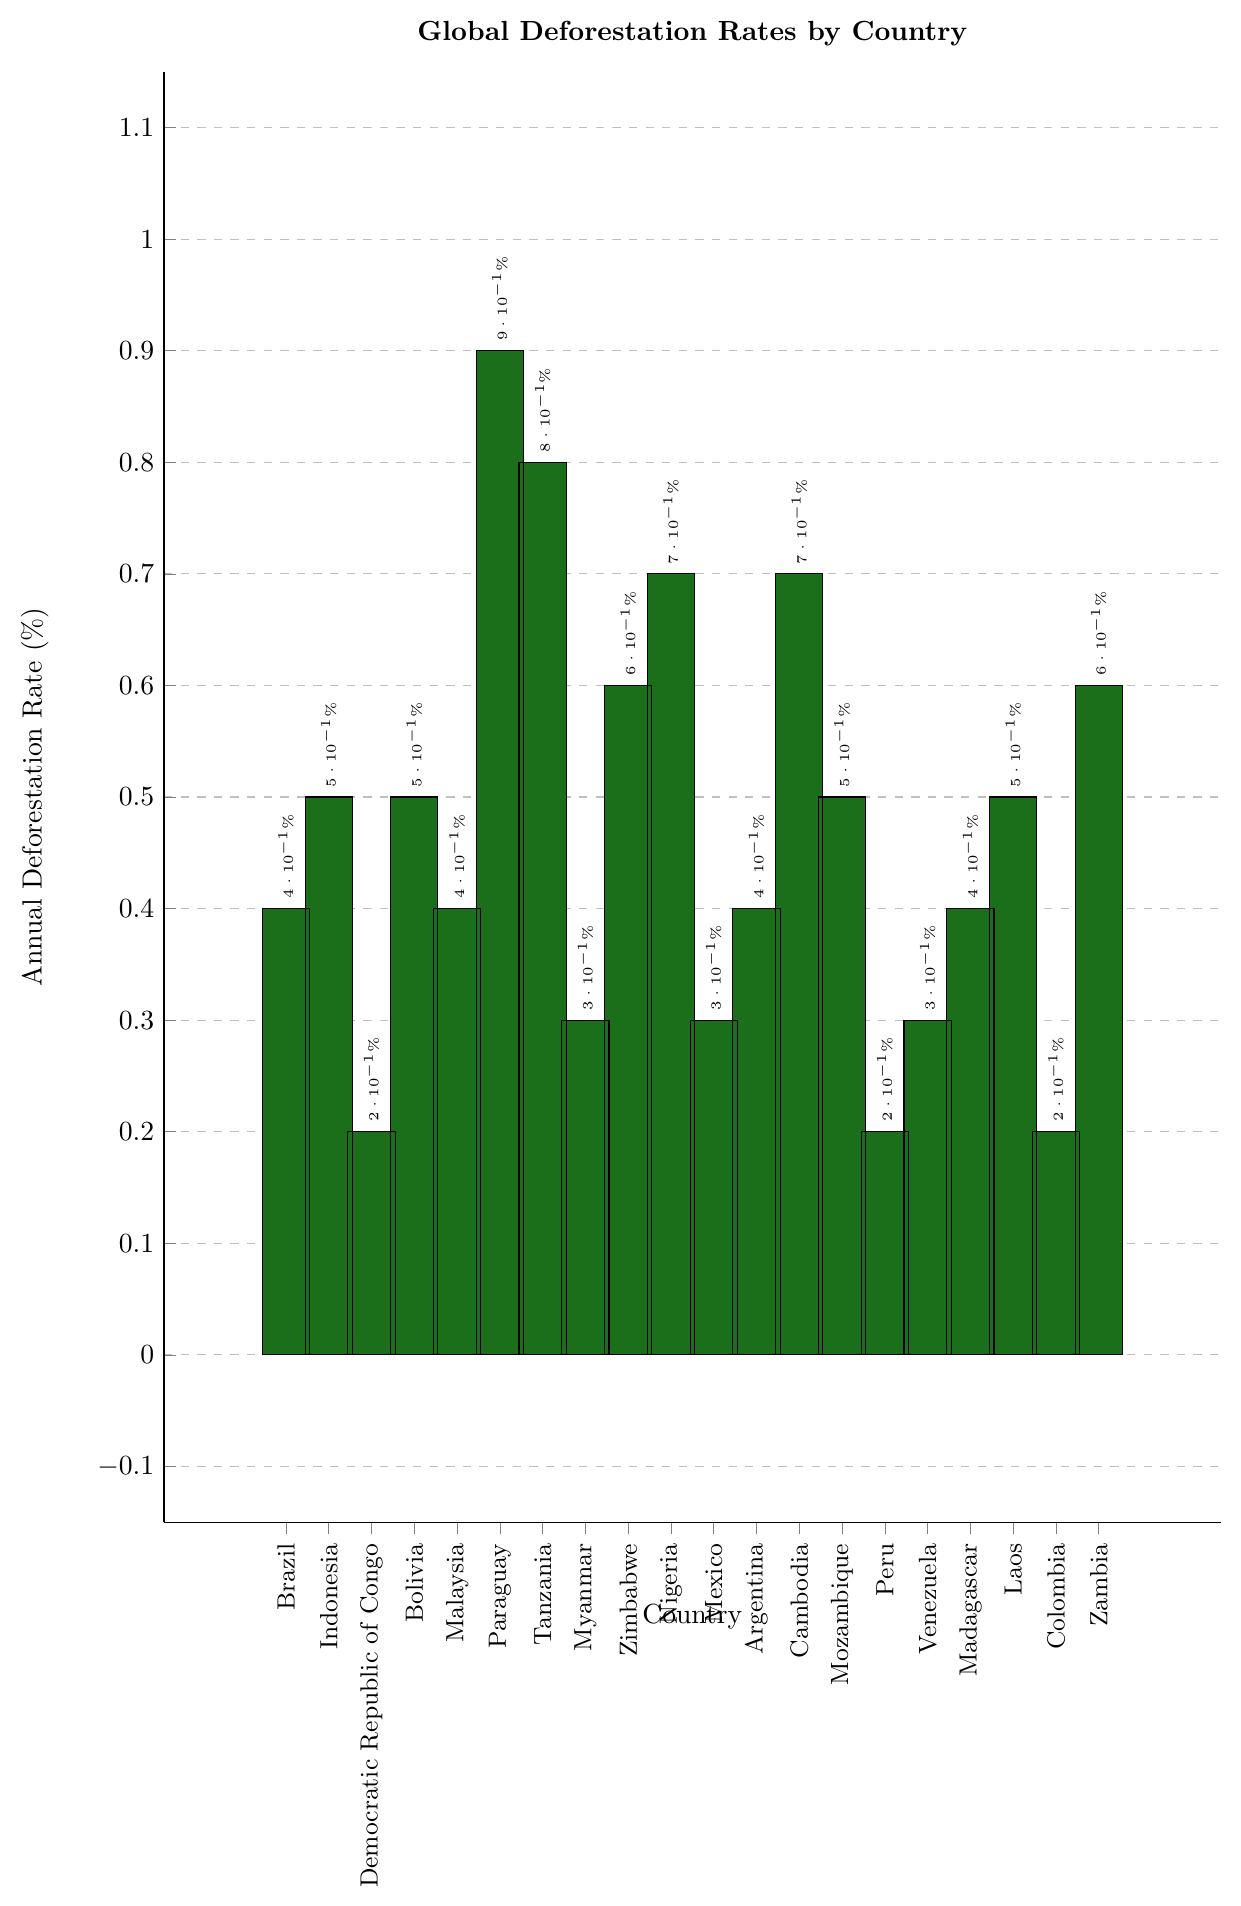What is the country with the highest deforestation rate? According to the chart, we observe the bars and compare their heights. Paraguay has the highest bar, indicating its annual deforestation rate.
Answer: Paraguay Which two countries have the same deforestation rate of 0.40%? To answer this, we examine the figure and find bars of the same height at 0.40%. Brazil, Malaysia, Argentina, and Madagascar all have the same height, so any combination of two from these countries is correct.
Answer: Brazil and Malaysia How much higher is Tanzania's deforestation rate compared to Zimbabwe's? Tanzania's deforestation rate is 0.80%, and Zimbabwe's is 0.60%. Subtract Zimbabwe's rate from Tanzania's rate (0.80% - 0.60%).
Answer: 0.20% Identify the country with an annual deforestation rate of 0.50% and caused by palm oil plantations. We need to find the country with a bar at 0.50% height and match with the provided data on causes. Indonesia fits this description.
Answer: Indonesia What is the average deforestation rate of the countries in the chart? Sum the deforestation rates of all countries: (0.40 + 0.50 + 0.20 + 0.50 + 0.40 + 0.90 + 0.80 + 0.30 + 0.60 + 0.70 + 0.30 + 0.40 + 0.70 + 0.50 + 0.20 + 0.30 + 0.40 + 0.50 + 0.20 + 0.60) = 10.60. Divide by the number of countries (20).
Answer: 0.53% Which country has a higher deforestation rate, Mozambique or Myanmar? Comparing the heights of the bars, Mozambique's bar at 0.50% is higher than Myanmar's at 0.30%.
Answer: Mozambique What is the sum of deforestation rates for countries involved in soybean cultivation? Identify the countries with "Soybean cultivation" as the cause (Bolivia, Argentina), and sum their rates: 0.50% + 0.40%.
Answer: 0.90% How many countries have an annual deforestation rate at or above 0.60%? Identify and count the bars at ≥0.60% height: Paraguay (0.90%), Tanzania (0.80%), Nigeria (0.70%), Cambodia (0.70%), Zimbabwe (0.60%), Zambia (0.60%).
Answer: 6 